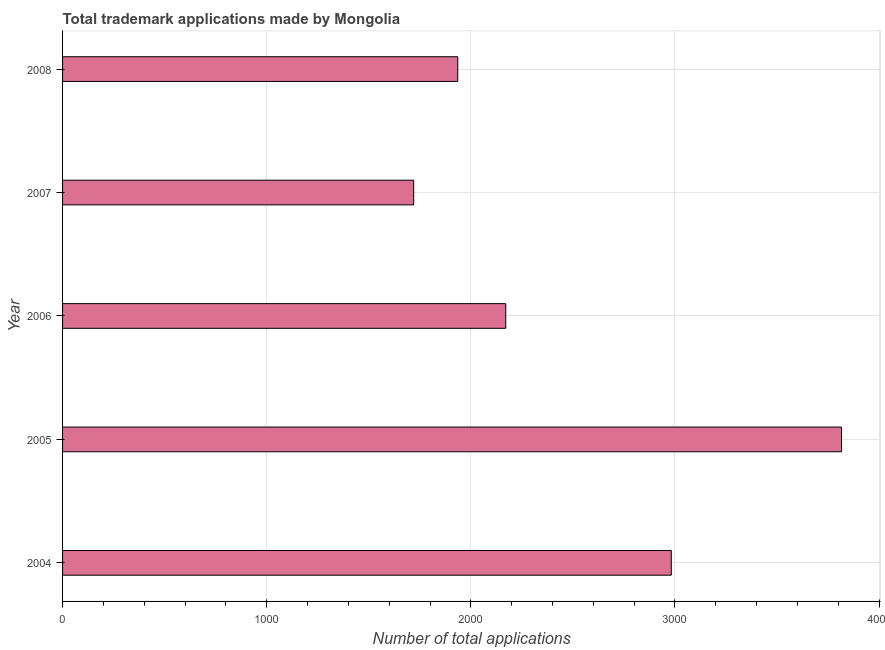Does the graph contain grids?
Provide a short and direct response. Yes. What is the title of the graph?
Your response must be concise. Total trademark applications made by Mongolia. What is the label or title of the X-axis?
Offer a very short reply. Number of total applications. What is the number of trademark applications in 2006?
Your answer should be very brief. 2171. Across all years, what is the maximum number of trademark applications?
Ensure brevity in your answer.  3816. Across all years, what is the minimum number of trademark applications?
Provide a short and direct response. 1720. In which year was the number of trademark applications minimum?
Offer a very short reply. 2007. What is the sum of the number of trademark applications?
Offer a terse response. 1.26e+04. What is the difference between the number of trademark applications in 2004 and 2008?
Keep it short and to the point. 1046. What is the average number of trademark applications per year?
Keep it short and to the point. 2525. What is the median number of trademark applications?
Provide a short and direct response. 2171. In how many years, is the number of trademark applications greater than 2400 ?
Ensure brevity in your answer.  2. Do a majority of the years between 2008 and 2004 (inclusive) have number of trademark applications greater than 3000 ?
Offer a very short reply. Yes. What is the ratio of the number of trademark applications in 2004 to that in 2006?
Ensure brevity in your answer.  1.37. Is the number of trademark applications in 2007 less than that in 2008?
Offer a very short reply. Yes. Is the difference between the number of trademark applications in 2007 and 2008 greater than the difference between any two years?
Give a very brief answer. No. What is the difference between the highest and the second highest number of trademark applications?
Offer a very short reply. 834. What is the difference between the highest and the lowest number of trademark applications?
Keep it short and to the point. 2096. In how many years, is the number of trademark applications greater than the average number of trademark applications taken over all years?
Keep it short and to the point. 2. How many bars are there?
Offer a terse response. 5. Are all the bars in the graph horizontal?
Your answer should be very brief. Yes. How many years are there in the graph?
Provide a short and direct response. 5. Are the values on the major ticks of X-axis written in scientific E-notation?
Ensure brevity in your answer.  No. What is the Number of total applications of 2004?
Your answer should be compact. 2982. What is the Number of total applications of 2005?
Your answer should be very brief. 3816. What is the Number of total applications of 2006?
Your answer should be very brief. 2171. What is the Number of total applications of 2007?
Offer a terse response. 1720. What is the Number of total applications in 2008?
Provide a succinct answer. 1936. What is the difference between the Number of total applications in 2004 and 2005?
Offer a terse response. -834. What is the difference between the Number of total applications in 2004 and 2006?
Offer a very short reply. 811. What is the difference between the Number of total applications in 2004 and 2007?
Offer a terse response. 1262. What is the difference between the Number of total applications in 2004 and 2008?
Your answer should be very brief. 1046. What is the difference between the Number of total applications in 2005 and 2006?
Give a very brief answer. 1645. What is the difference between the Number of total applications in 2005 and 2007?
Provide a succinct answer. 2096. What is the difference between the Number of total applications in 2005 and 2008?
Your response must be concise. 1880. What is the difference between the Number of total applications in 2006 and 2007?
Provide a succinct answer. 451. What is the difference between the Number of total applications in 2006 and 2008?
Provide a short and direct response. 235. What is the difference between the Number of total applications in 2007 and 2008?
Offer a very short reply. -216. What is the ratio of the Number of total applications in 2004 to that in 2005?
Make the answer very short. 0.78. What is the ratio of the Number of total applications in 2004 to that in 2006?
Offer a very short reply. 1.37. What is the ratio of the Number of total applications in 2004 to that in 2007?
Offer a terse response. 1.73. What is the ratio of the Number of total applications in 2004 to that in 2008?
Your response must be concise. 1.54. What is the ratio of the Number of total applications in 2005 to that in 2006?
Provide a short and direct response. 1.76. What is the ratio of the Number of total applications in 2005 to that in 2007?
Ensure brevity in your answer.  2.22. What is the ratio of the Number of total applications in 2005 to that in 2008?
Your answer should be very brief. 1.97. What is the ratio of the Number of total applications in 2006 to that in 2007?
Provide a short and direct response. 1.26. What is the ratio of the Number of total applications in 2006 to that in 2008?
Provide a succinct answer. 1.12. What is the ratio of the Number of total applications in 2007 to that in 2008?
Offer a terse response. 0.89. 